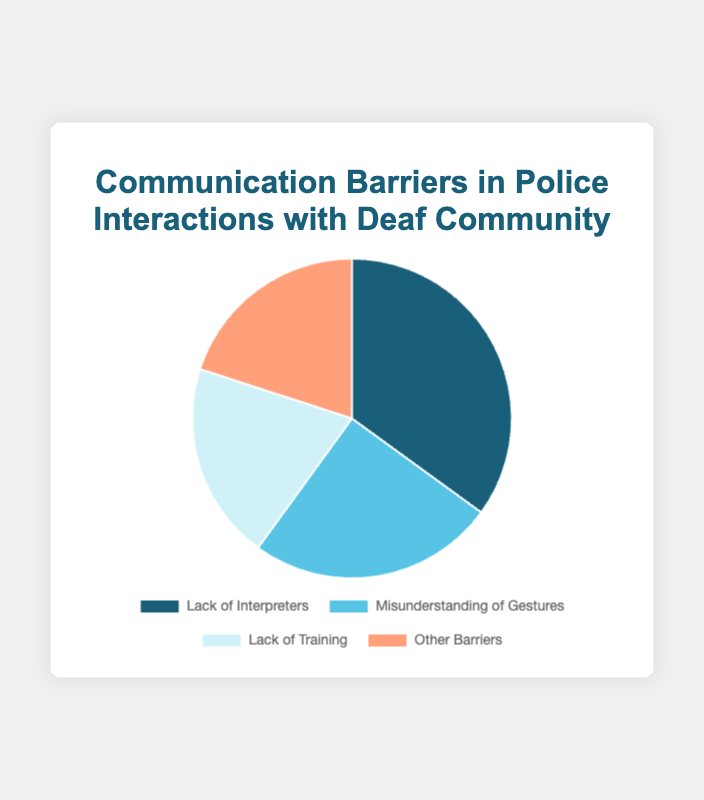Which communication barrier has the highest percentage? To find the communication barrier with the highest percentage, look for the largest portion of the pie chart. "Lack of Interpreters" occupies the largest segment with 35%.
Answer: Lack of Interpreters Which two barriers have the same percentage? Look for segments that are equal in size. Both "Lack of Training" and "Other Barriers" have a 20% share in the pie chart.
Answer: Lack of Training and Other Barriers Which communication barrier has the smallest percentage? Identify the smallest segment in the pie chart. "Lack of Training" and "Other Barriers" are both the smallest, each with 20%.
Answer: Lack of Training and Other Barriers What is the combined percentage of 'Lack of Training' and 'Other Barriers'? Sum the percentages of "Lack of Training" and "Other Barriers". 20% + 20% = 40%.
Answer: 40% What is the difference in percentage between 'Lack of Interpreters' and 'Misunderstanding of Gestures'? Subtract the percentage of "Misunderstanding of Gestures" from "Lack of Interpreters". 35% - 25% = 10%.
Answer: 10% How many barriers have a percentage higher than 20%? Count the segments with a percentage greater than 20%. "Lack of Interpreters" (35%) and "Misunderstanding of Gestures" (25%) meet this criterion.
Answer: 2 If you were to merge 'Misunderstanding of Gestures' and 'Other Barriers', what percentage would they cover? Add the percentages of "Misunderstanding of Gestures" and "Other Barriers". 25% + 20% = 45%.
Answer: 45% Identify the second largest communication barrier by percentage. Locate the segment which is the second largest after the largest one ("Lack of Interpreters" at 35%). "Misunderstanding of Gestures" is the second largest at 25%.
Answer: Misunderstanding of Gestures What percentage of communication barriers are not related to interpreters or gestures? Sum the percentages of barriers that do not include interpreters or gestures, i.e., "Lack of Training" and "Other Barriers". 20% + 20% = 40%.
Answer: 40% Between 'Lack of Interpreters' and 'Lack of Training', which barrier is more prevalent and by what margin? "Lack of Interpreters" has 35% and "Lack of Training" has 20%. The margin is 35% - 20% = 15%.
Answer: Lack of Interpreters by 15% 